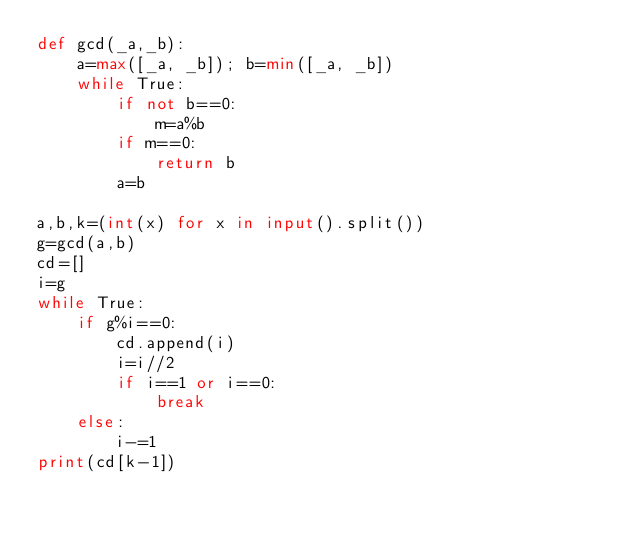Convert code to text. <code><loc_0><loc_0><loc_500><loc_500><_Python_>def gcd(_a,_b):
    a=max([_a, _b]); b=min([_a, _b])
    while True:
        if not b==0:
            m=a%b
        if m==0:
            return b
        a=b

a,b,k=(int(x) for x in input().split())
g=gcd(a,b)
cd=[]
i=g
while True:
    if g%i==0:
        cd.append(i)
        i=i//2
        if i==1 or i==0:
            break
    else:
        i-=1
print(cd[k-1])</code> 